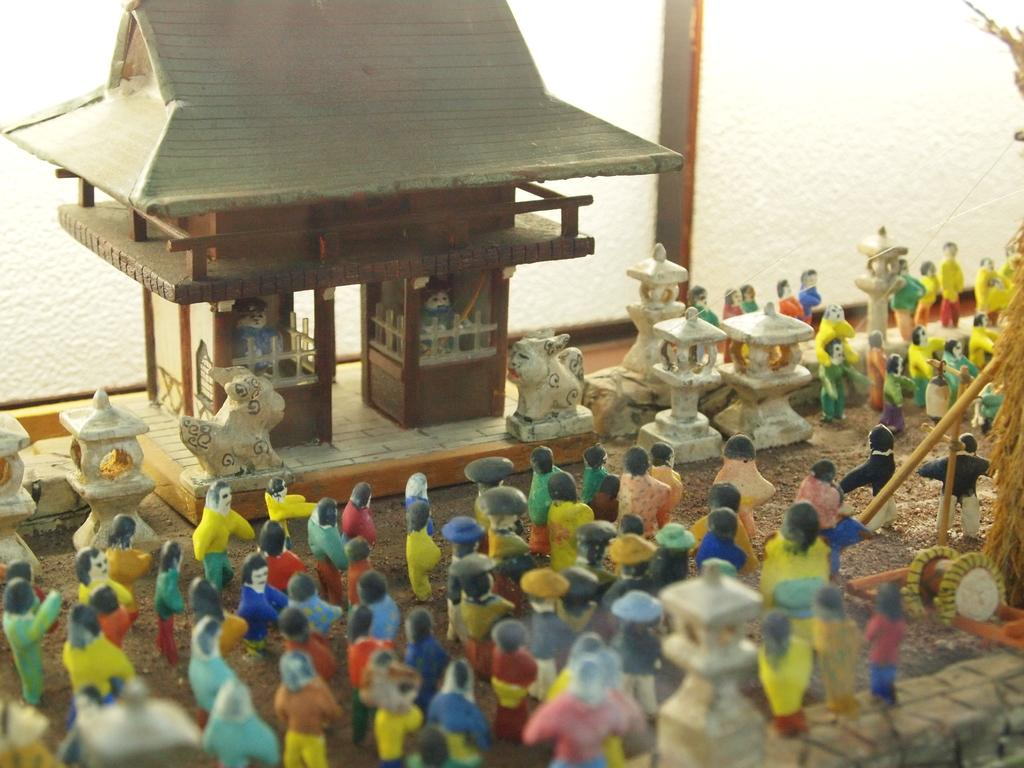What can be seen standing on the ground in the image? There is a group of dolls standing on the ground. What is visible in the background of the image? There is a toy house in the background. Are there any toys inside the toy house? Yes, two toys are placed inside the toy house. What is the plot of the story being written by the writer in the image? There is no writer or story being written in the image; it features a group of dolls and a toy house. 